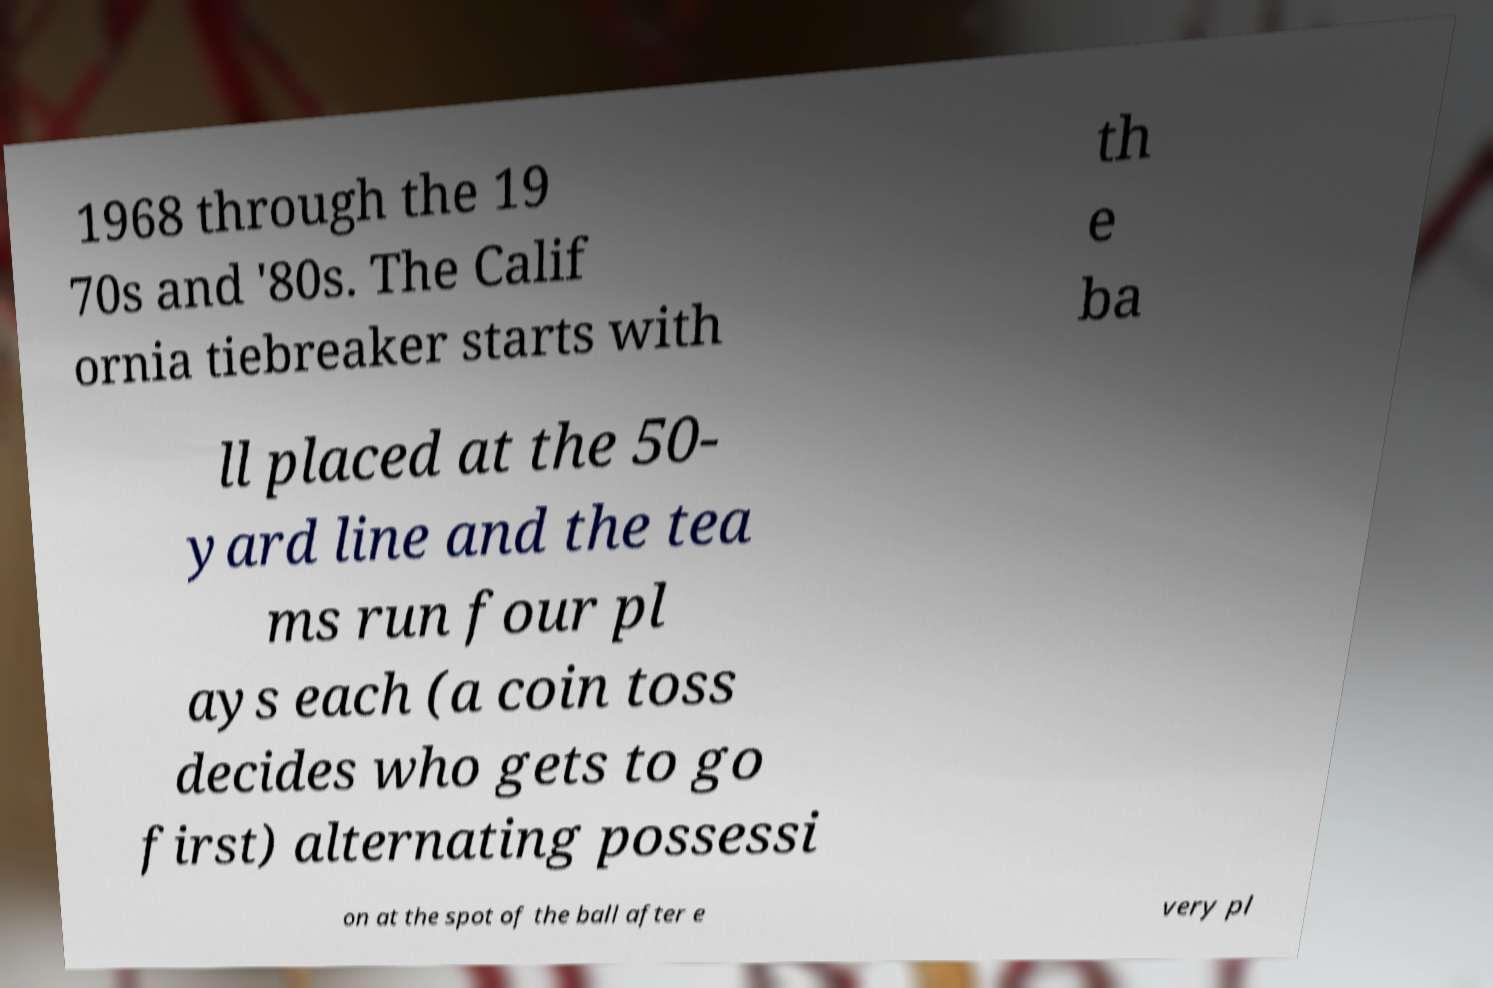There's text embedded in this image that I need extracted. Can you transcribe it verbatim? 1968 through the 19 70s and '80s. The Calif ornia tiebreaker starts with th e ba ll placed at the 50- yard line and the tea ms run four pl ays each (a coin toss decides who gets to go first) alternating possessi on at the spot of the ball after e very pl 